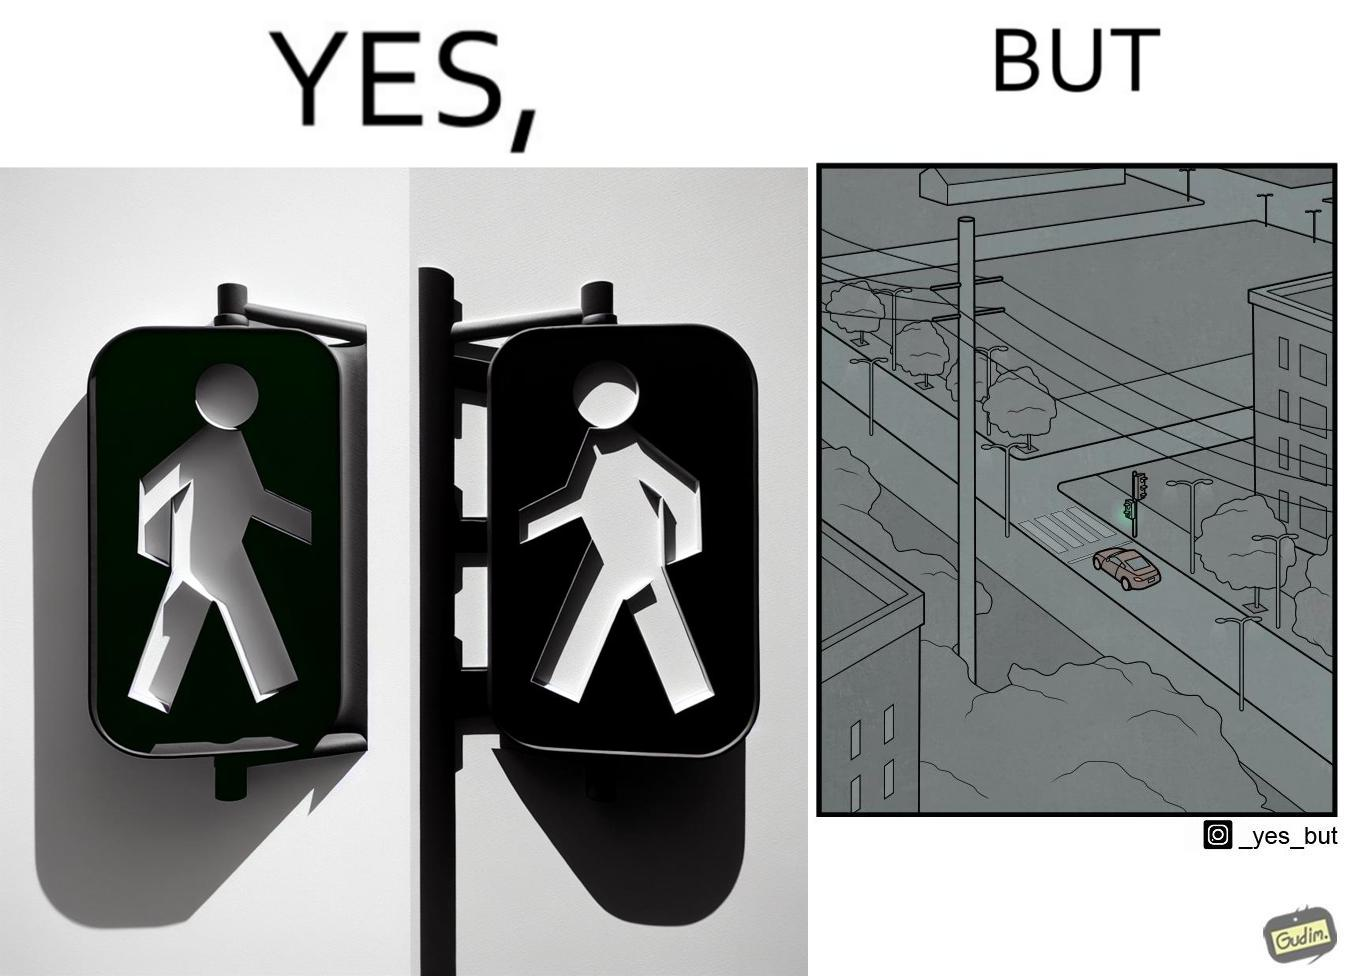What do you see in each half of this image? In the left part of the image: The image shows the walk sign turned to green on a traffic signal. In the right part of the image: The image shows an empty road with only one car on the road. The car is waiting for the walk sign to turn to red so that it can cross the zebra crossing.  There is no one else on the road except from the car. 